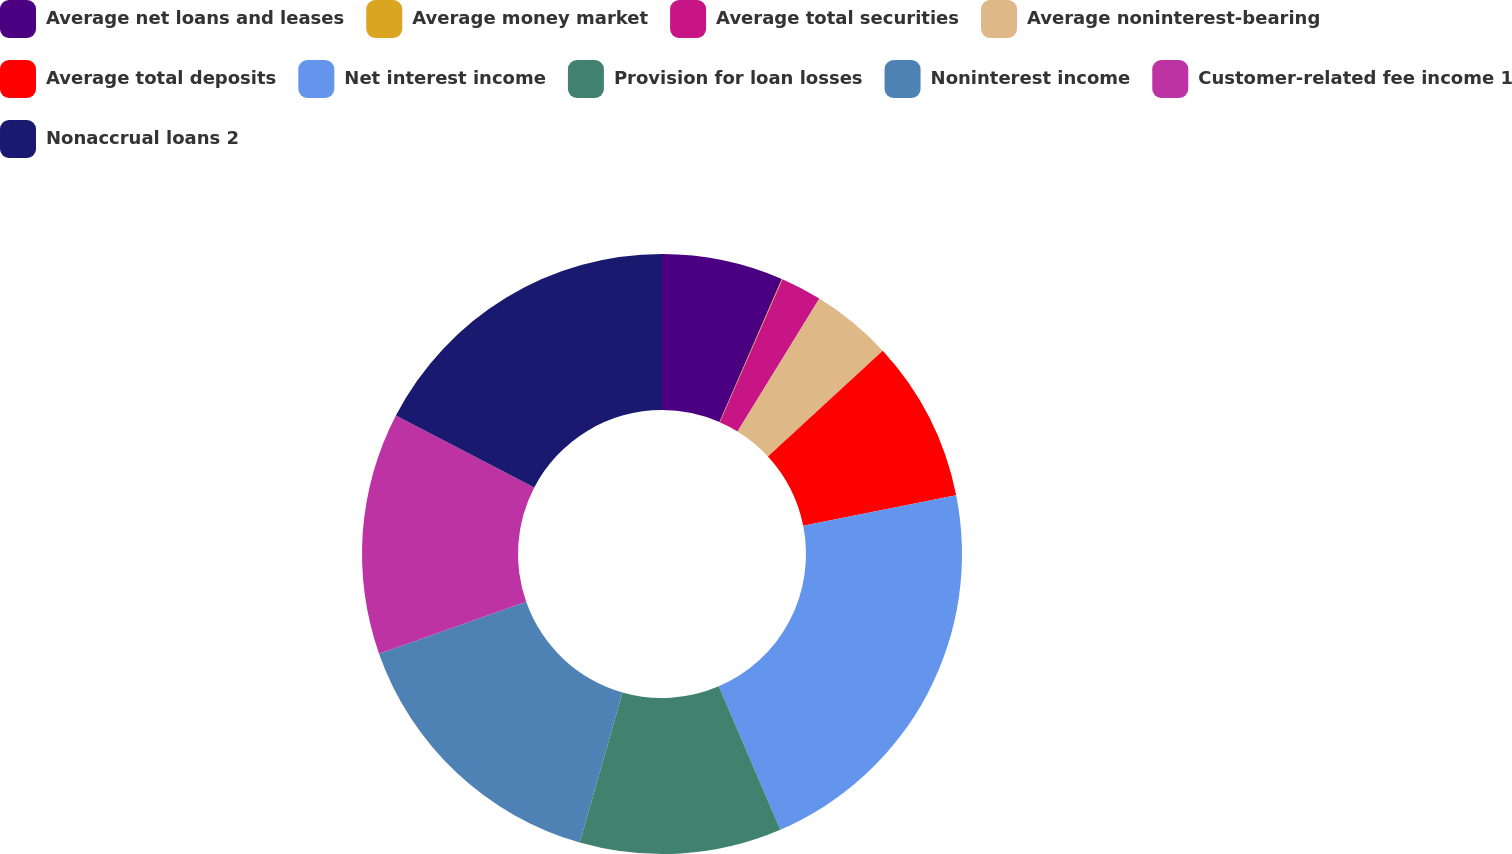Convert chart to OTSL. <chart><loc_0><loc_0><loc_500><loc_500><pie_chart><fcel>Average net loans and leases<fcel>Average money market<fcel>Average total securities<fcel>Average noninterest-bearing<fcel>Average total deposits<fcel>Net interest income<fcel>Provision for loan losses<fcel>Noninterest income<fcel>Customer-related fee income 1<fcel>Nonaccrual loans 2<nl><fcel>6.54%<fcel>0.04%<fcel>2.21%<fcel>4.37%<fcel>8.7%<fcel>21.69%<fcel>10.87%<fcel>15.19%<fcel>13.03%<fcel>17.36%<nl></chart> 